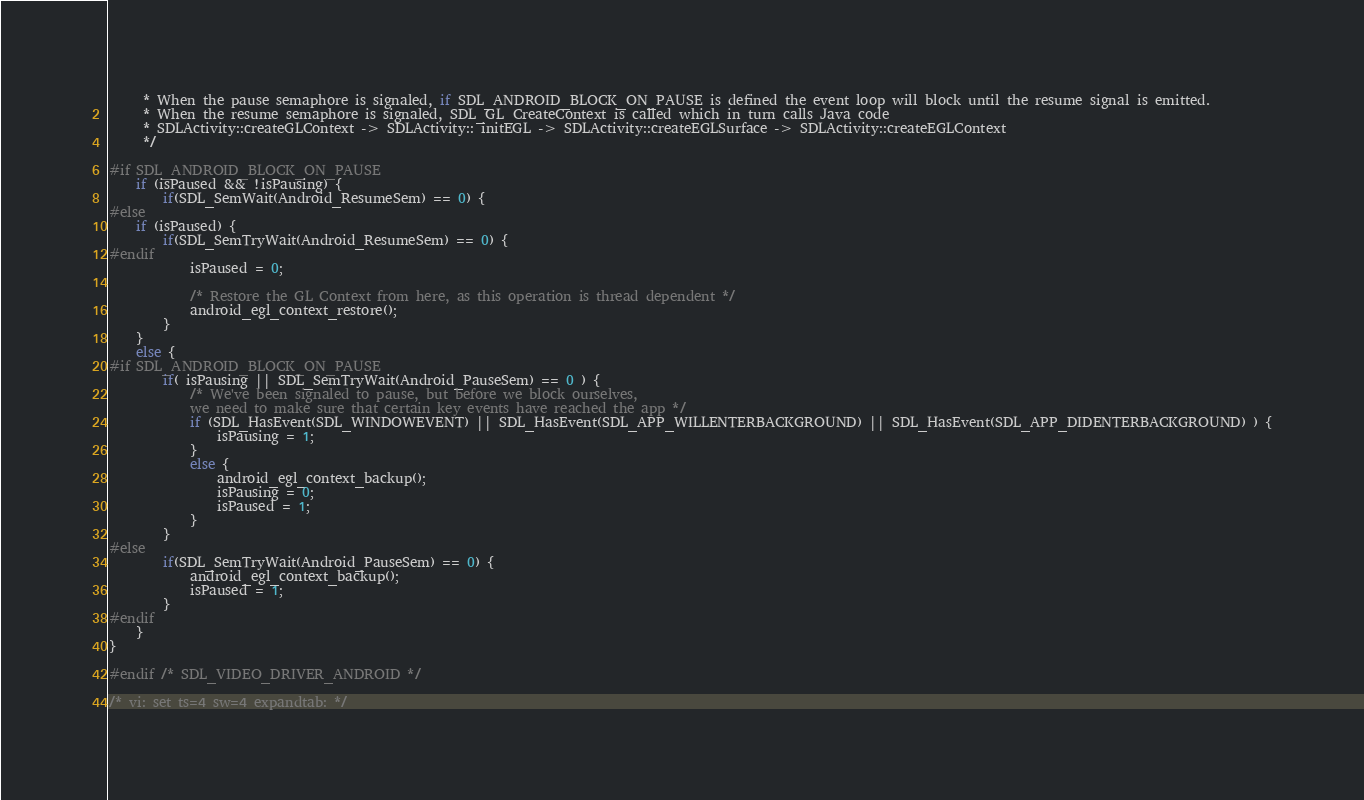<code> <loc_0><loc_0><loc_500><loc_500><_C_>     * When the pause semaphore is signaled, if SDL_ANDROID_BLOCK_ON_PAUSE is defined the event loop will block until the resume signal is emitted.
     * When the resume semaphore is signaled, SDL_GL_CreateContext is called which in turn calls Java code
     * SDLActivity::createGLContext -> SDLActivity:: initEGL -> SDLActivity::createEGLSurface -> SDLActivity::createEGLContext
     */

#if SDL_ANDROID_BLOCK_ON_PAUSE
    if (isPaused && !isPausing) {
        if(SDL_SemWait(Android_ResumeSem) == 0) {
#else
    if (isPaused) {
        if(SDL_SemTryWait(Android_ResumeSem) == 0) {
#endif
            isPaused = 0;
            
            /* Restore the GL Context from here, as this operation is thread dependent */
            android_egl_context_restore();
        }
    }
    else {
#if SDL_ANDROID_BLOCK_ON_PAUSE
        if( isPausing || SDL_SemTryWait(Android_PauseSem) == 0 ) {
            /* We've been signaled to pause, but before we block ourselves, 
            we need to make sure that certain key events have reached the app */
            if (SDL_HasEvent(SDL_WINDOWEVENT) || SDL_HasEvent(SDL_APP_WILLENTERBACKGROUND) || SDL_HasEvent(SDL_APP_DIDENTERBACKGROUND) ) {
                isPausing = 1;
            }
            else {
                android_egl_context_backup();
                isPausing = 0;
                isPaused = 1;
            }
        }
#else
        if(SDL_SemTryWait(Android_PauseSem) == 0) {
            android_egl_context_backup();
            isPaused = 1;
        }
#endif
    }
}

#endif /* SDL_VIDEO_DRIVER_ANDROID */

/* vi: set ts=4 sw=4 expandtab: */
</code> 